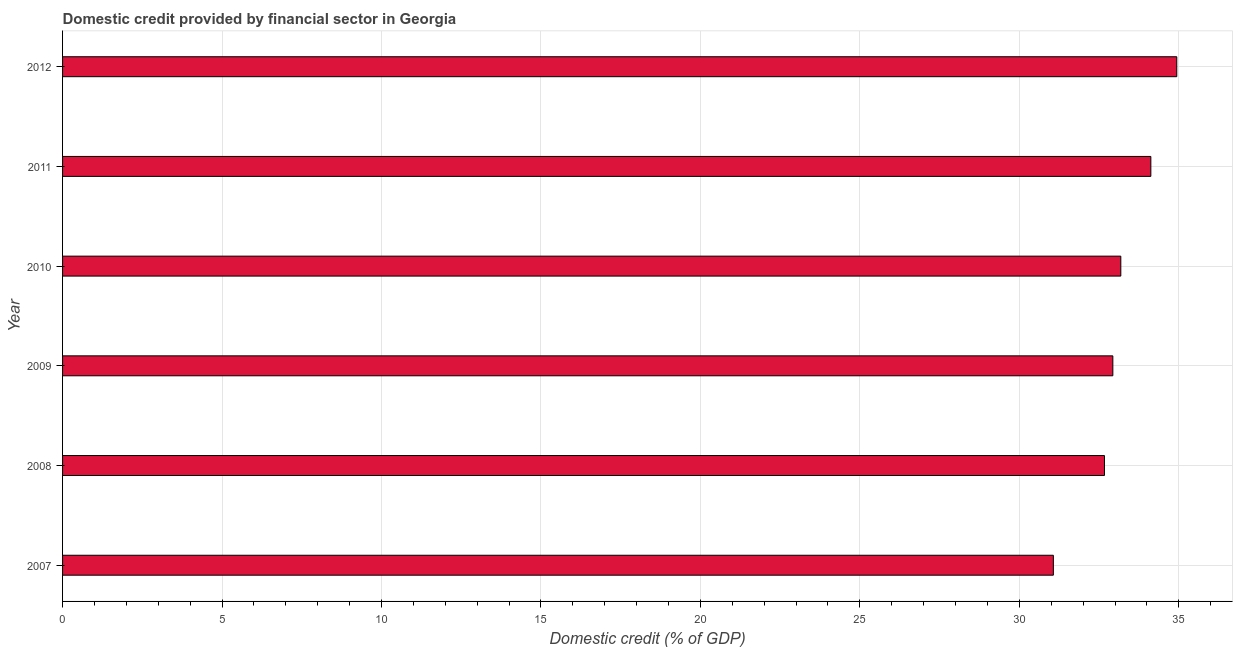Does the graph contain grids?
Keep it short and to the point. Yes. What is the title of the graph?
Provide a succinct answer. Domestic credit provided by financial sector in Georgia. What is the label or title of the X-axis?
Offer a terse response. Domestic credit (% of GDP). What is the label or title of the Y-axis?
Provide a short and direct response. Year. What is the domestic credit provided by financial sector in 2007?
Ensure brevity in your answer.  31.07. Across all years, what is the maximum domestic credit provided by financial sector?
Make the answer very short. 34.94. Across all years, what is the minimum domestic credit provided by financial sector?
Ensure brevity in your answer.  31.07. In which year was the domestic credit provided by financial sector maximum?
Ensure brevity in your answer.  2012. In which year was the domestic credit provided by financial sector minimum?
Your response must be concise. 2007. What is the sum of the domestic credit provided by financial sector?
Your answer should be very brief. 198.91. What is the difference between the domestic credit provided by financial sector in 2007 and 2010?
Ensure brevity in your answer.  -2.12. What is the average domestic credit provided by financial sector per year?
Ensure brevity in your answer.  33.15. What is the median domestic credit provided by financial sector?
Your answer should be very brief. 33.06. Do a majority of the years between 2008 and 2011 (inclusive) have domestic credit provided by financial sector greater than 27 %?
Your response must be concise. Yes. What is the ratio of the domestic credit provided by financial sector in 2009 to that in 2012?
Offer a very short reply. 0.94. What is the difference between the highest and the second highest domestic credit provided by financial sector?
Make the answer very short. 0.81. Is the sum of the domestic credit provided by financial sector in 2009 and 2012 greater than the maximum domestic credit provided by financial sector across all years?
Offer a terse response. Yes. What is the difference between the highest and the lowest domestic credit provided by financial sector?
Give a very brief answer. 3.87. In how many years, is the domestic credit provided by financial sector greater than the average domestic credit provided by financial sector taken over all years?
Provide a short and direct response. 3. How many bars are there?
Give a very brief answer. 6. Are all the bars in the graph horizontal?
Your answer should be very brief. Yes. What is the difference between two consecutive major ticks on the X-axis?
Ensure brevity in your answer.  5. Are the values on the major ticks of X-axis written in scientific E-notation?
Your answer should be compact. No. What is the Domestic credit (% of GDP) of 2007?
Keep it short and to the point. 31.07. What is the Domestic credit (% of GDP) of 2008?
Give a very brief answer. 32.67. What is the Domestic credit (% of GDP) in 2009?
Your response must be concise. 32.93. What is the Domestic credit (% of GDP) in 2010?
Make the answer very short. 33.18. What is the Domestic credit (% of GDP) in 2011?
Your response must be concise. 34.12. What is the Domestic credit (% of GDP) of 2012?
Your answer should be compact. 34.94. What is the difference between the Domestic credit (% of GDP) in 2007 and 2008?
Give a very brief answer. -1.6. What is the difference between the Domestic credit (% of GDP) in 2007 and 2009?
Your answer should be compact. -1.87. What is the difference between the Domestic credit (% of GDP) in 2007 and 2010?
Ensure brevity in your answer.  -2.12. What is the difference between the Domestic credit (% of GDP) in 2007 and 2011?
Ensure brevity in your answer.  -3.06. What is the difference between the Domestic credit (% of GDP) in 2007 and 2012?
Offer a terse response. -3.87. What is the difference between the Domestic credit (% of GDP) in 2008 and 2009?
Your answer should be compact. -0.26. What is the difference between the Domestic credit (% of GDP) in 2008 and 2010?
Provide a succinct answer. -0.51. What is the difference between the Domestic credit (% of GDP) in 2008 and 2011?
Provide a succinct answer. -1.45. What is the difference between the Domestic credit (% of GDP) in 2008 and 2012?
Your answer should be very brief. -2.27. What is the difference between the Domestic credit (% of GDP) in 2009 and 2010?
Provide a succinct answer. -0.25. What is the difference between the Domestic credit (% of GDP) in 2009 and 2011?
Your response must be concise. -1.19. What is the difference between the Domestic credit (% of GDP) in 2009 and 2012?
Give a very brief answer. -2. What is the difference between the Domestic credit (% of GDP) in 2010 and 2011?
Keep it short and to the point. -0.94. What is the difference between the Domestic credit (% of GDP) in 2010 and 2012?
Your answer should be very brief. -1.75. What is the difference between the Domestic credit (% of GDP) in 2011 and 2012?
Provide a succinct answer. -0.81. What is the ratio of the Domestic credit (% of GDP) in 2007 to that in 2008?
Your answer should be very brief. 0.95. What is the ratio of the Domestic credit (% of GDP) in 2007 to that in 2009?
Make the answer very short. 0.94. What is the ratio of the Domestic credit (% of GDP) in 2007 to that in 2010?
Your response must be concise. 0.94. What is the ratio of the Domestic credit (% of GDP) in 2007 to that in 2011?
Give a very brief answer. 0.91. What is the ratio of the Domestic credit (% of GDP) in 2007 to that in 2012?
Provide a succinct answer. 0.89. What is the ratio of the Domestic credit (% of GDP) in 2008 to that in 2012?
Your answer should be compact. 0.94. What is the ratio of the Domestic credit (% of GDP) in 2009 to that in 2012?
Offer a very short reply. 0.94. What is the ratio of the Domestic credit (% of GDP) in 2010 to that in 2011?
Make the answer very short. 0.97. What is the ratio of the Domestic credit (% of GDP) in 2010 to that in 2012?
Your answer should be compact. 0.95. What is the ratio of the Domestic credit (% of GDP) in 2011 to that in 2012?
Offer a terse response. 0.98. 